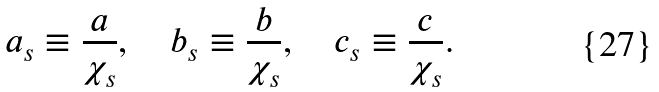Convert formula to latex. <formula><loc_0><loc_0><loc_500><loc_500>a _ { s } \equiv \frac { a } { \chi _ { s } } , \quad b _ { s } \equiv \frac { b } { \chi _ { s } } , \quad c _ { s } \equiv \frac { c } { \chi _ { s } } .</formula> 